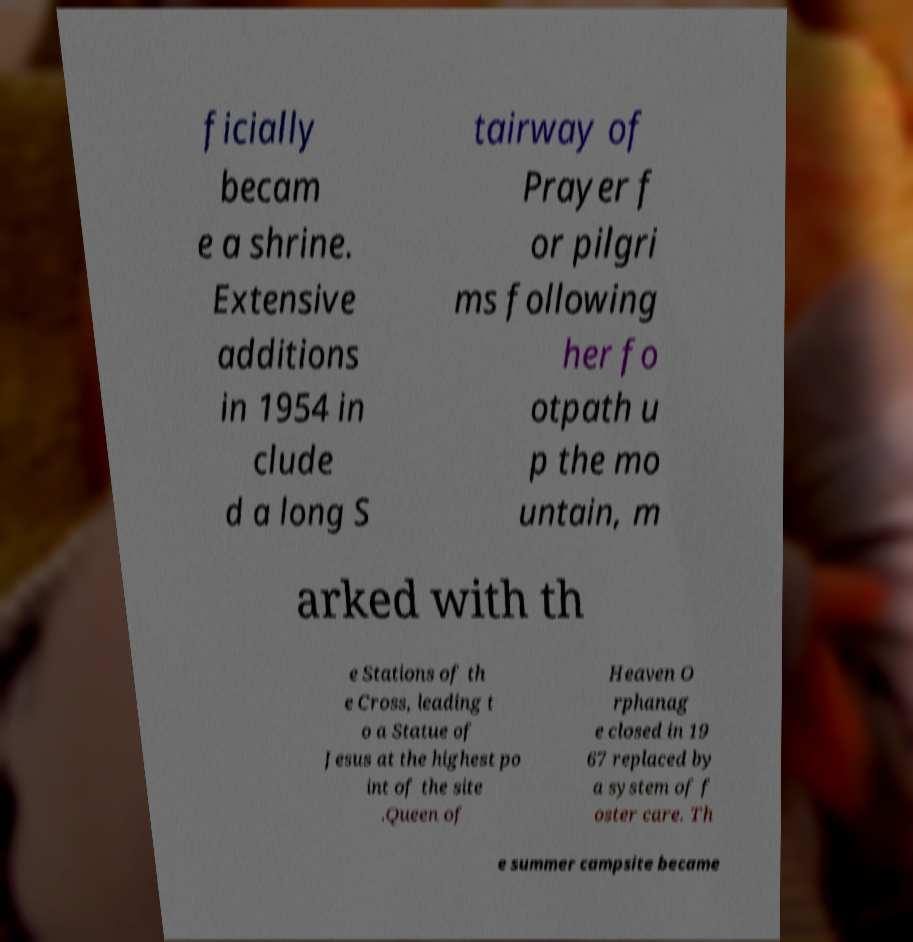Please read and relay the text visible in this image. What does it say? ficially becam e a shrine. Extensive additions in 1954 in clude d a long S tairway of Prayer f or pilgri ms following her fo otpath u p the mo untain, m arked with th e Stations of th e Cross, leading t o a Statue of Jesus at the highest po int of the site .Queen of Heaven O rphanag e closed in 19 67 replaced by a system of f oster care. Th e summer campsite became 